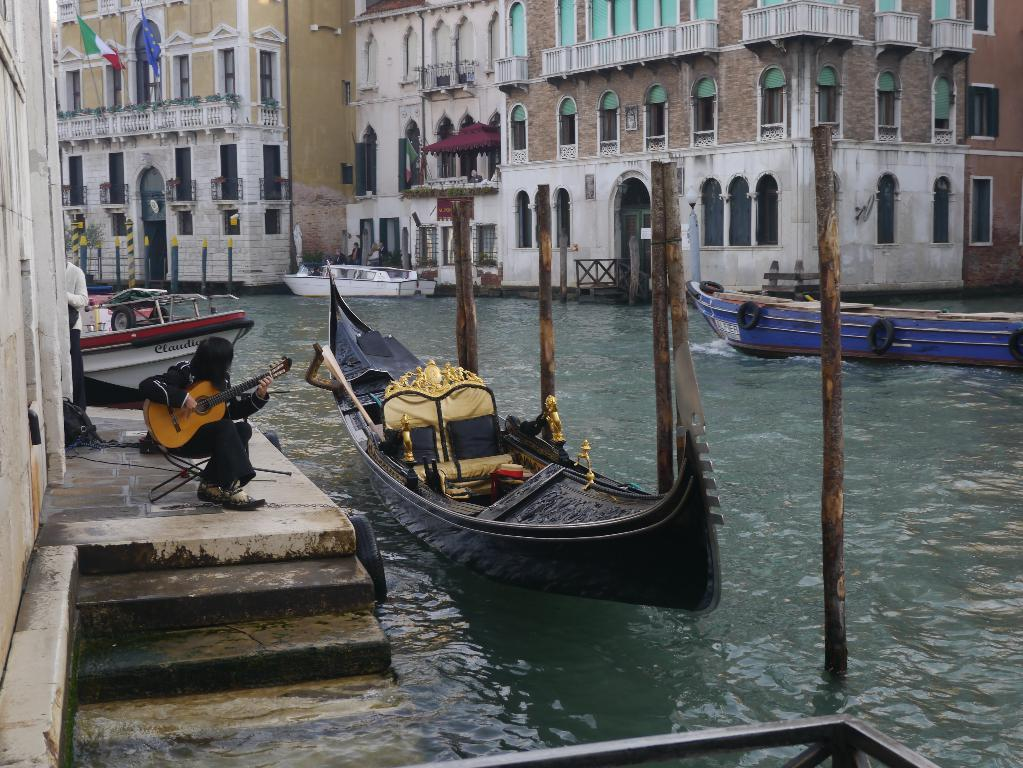What is the person in the image doing? The person is sitting and playing a guitar in the image. What can be seen in the water in the image? There is a boat in the water in the image. What else can be seen in the background of the image? There are other boats and a building visible in the background of the image. What is the flag associated with in the image? The flag is associated with the building in the background of the image. What song is the person playing on the guitar in the image? There is no information about the song being played in the image. 